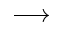<formula> <loc_0><loc_0><loc_500><loc_500>\longrightarrow</formula> 